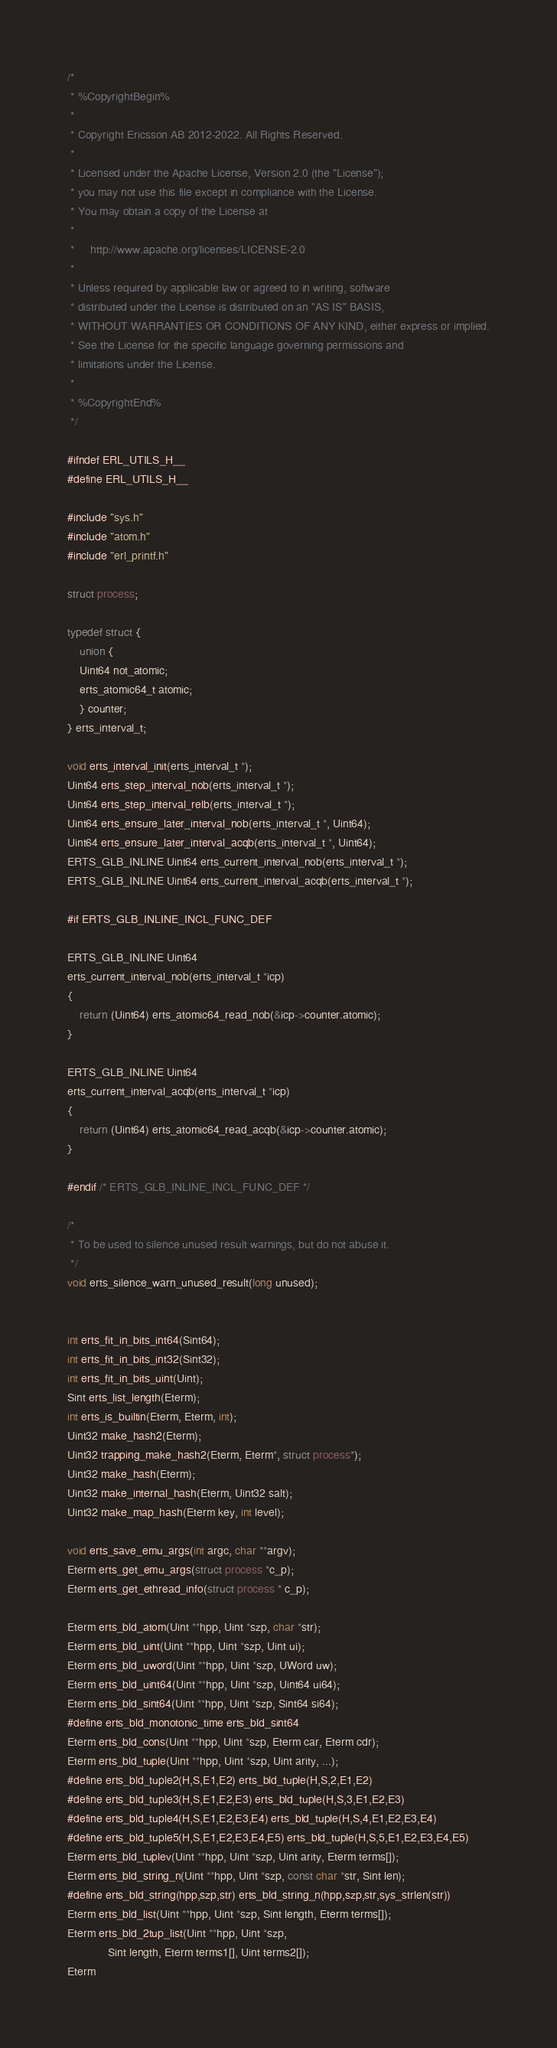Convert code to text. <code><loc_0><loc_0><loc_500><loc_500><_C_>/*
 * %CopyrightBegin%
 *
 * Copyright Ericsson AB 2012-2022. All Rights Reserved.
 *
 * Licensed under the Apache License, Version 2.0 (the "License");
 * you may not use this file except in compliance with the License.
 * You may obtain a copy of the License at
 *
 *     http://www.apache.org/licenses/LICENSE-2.0
 *
 * Unless required by applicable law or agreed to in writing, software
 * distributed under the License is distributed on an "AS IS" BASIS,
 * WITHOUT WARRANTIES OR CONDITIONS OF ANY KIND, either express or implied.
 * See the License for the specific language governing permissions and
 * limitations under the License.
 *
 * %CopyrightEnd%
 */

#ifndef ERL_UTILS_H__
#define ERL_UTILS_H__

#include "sys.h"
#include "atom.h"
#include "erl_printf.h"

struct process;

typedef struct {
    union {
	Uint64 not_atomic;
	erts_atomic64_t atomic;
    } counter;
} erts_interval_t;

void erts_interval_init(erts_interval_t *);
Uint64 erts_step_interval_nob(erts_interval_t *);
Uint64 erts_step_interval_relb(erts_interval_t *);
Uint64 erts_ensure_later_interval_nob(erts_interval_t *, Uint64);
Uint64 erts_ensure_later_interval_acqb(erts_interval_t *, Uint64);
ERTS_GLB_INLINE Uint64 erts_current_interval_nob(erts_interval_t *);
ERTS_GLB_INLINE Uint64 erts_current_interval_acqb(erts_interval_t *);

#if ERTS_GLB_INLINE_INCL_FUNC_DEF

ERTS_GLB_INLINE Uint64
erts_current_interval_nob(erts_interval_t *icp)
{
    return (Uint64) erts_atomic64_read_nob(&icp->counter.atomic);
}

ERTS_GLB_INLINE Uint64
erts_current_interval_acqb(erts_interval_t *icp)
{
    return (Uint64) erts_atomic64_read_acqb(&icp->counter.atomic);
}

#endif /* ERTS_GLB_INLINE_INCL_FUNC_DEF */

/*
 * To be used to silence unused result warnings, but do not abuse it.
 */
void erts_silence_warn_unused_result(long unused);


int erts_fit_in_bits_int64(Sint64);
int erts_fit_in_bits_int32(Sint32);
int erts_fit_in_bits_uint(Uint);
Sint erts_list_length(Eterm);
int erts_is_builtin(Eterm, Eterm, int);
Uint32 make_hash2(Eterm);
Uint32 trapping_make_hash2(Eterm, Eterm*, struct process*);
Uint32 make_hash(Eterm);
Uint32 make_internal_hash(Eterm, Uint32 salt);
Uint32 make_map_hash(Eterm key, int level);

void erts_save_emu_args(int argc, char **argv);
Eterm erts_get_emu_args(struct process *c_p);
Eterm erts_get_ethread_info(struct process * c_p);

Eterm erts_bld_atom(Uint **hpp, Uint *szp, char *str);
Eterm erts_bld_uint(Uint **hpp, Uint *szp, Uint ui);
Eterm erts_bld_uword(Uint **hpp, Uint *szp, UWord uw);
Eterm erts_bld_uint64(Uint **hpp, Uint *szp, Uint64 ui64);
Eterm erts_bld_sint64(Uint **hpp, Uint *szp, Sint64 si64);
#define erts_bld_monotonic_time erts_bld_sint64
Eterm erts_bld_cons(Uint **hpp, Uint *szp, Eterm car, Eterm cdr);
Eterm erts_bld_tuple(Uint **hpp, Uint *szp, Uint arity, ...);
#define erts_bld_tuple2(H,S,E1,E2) erts_bld_tuple(H,S,2,E1,E2)
#define erts_bld_tuple3(H,S,E1,E2,E3) erts_bld_tuple(H,S,3,E1,E2,E3)
#define erts_bld_tuple4(H,S,E1,E2,E3,E4) erts_bld_tuple(H,S,4,E1,E2,E3,E4)
#define erts_bld_tuple5(H,S,E1,E2,E3,E4,E5) erts_bld_tuple(H,S,5,E1,E2,E3,E4,E5)
Eterm erts_bld_tuplev(Uint **hpp, Uint *szp, Uint arity, Eterm terms[]);
Eterm erts_bld_string_n(Uint **hpp, Uint *szp, const char *str, Sint len);
#define erts_bld_string(hpp,szp,str) erts_bld_string_n(hpp,szp,str,sys_strlen(str))
Eterm erts_bld_list(Uint **hpp, Uint *szp, Sint length, Eterm terms[]);
Eterm erts_bld_2tup_list(Uint **hpp, Uint *szp,
			 Sint length, Eterm terms1[], Uint terms2[]);
Eterm</code> 